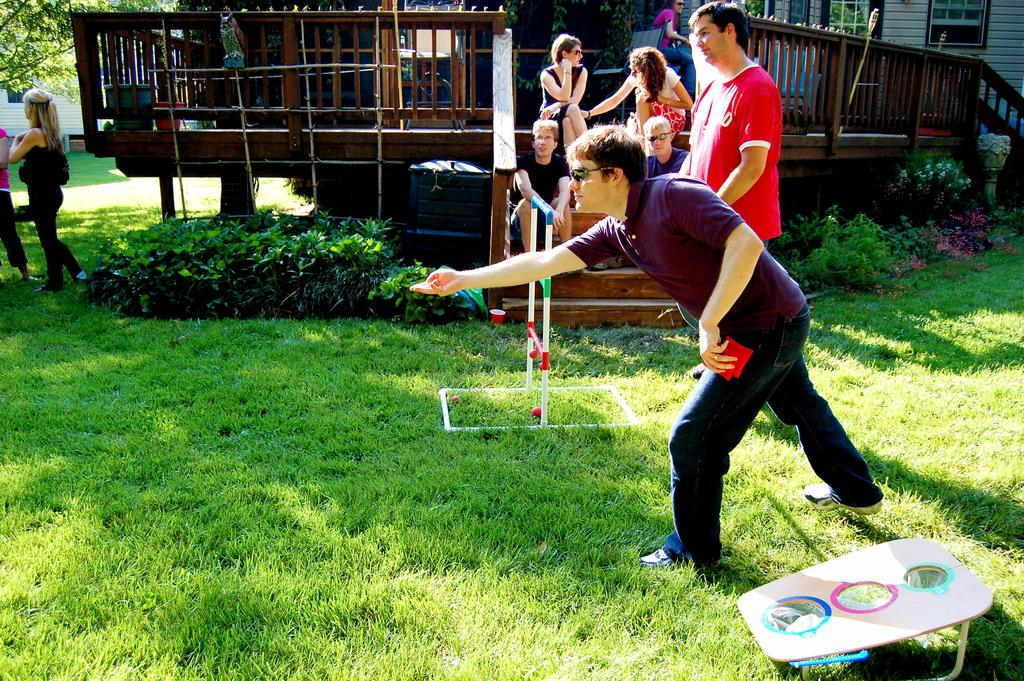What is the primary activity of the people in the image? Some people are standing, and some are sitting. Can you describe the positions of the people in the image? Some people are standing, and some are sitting. What celestial bodies are visible in the image? There are planets visible in the image. What type of structure is present in the image? There is a house in the image. How many pigs can be seen grazing near the house in the image? There are no pigs present in the image. What type of cactus is growing next to the house in the image? There is no cactus present in the image. 